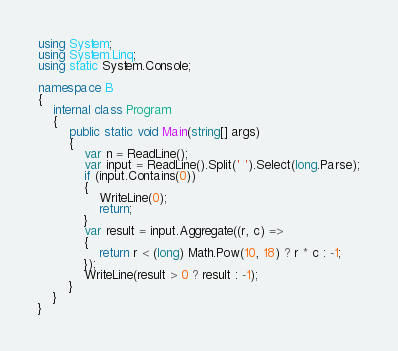Convert code to text. <code><loc_0><loc_0><loc_500><loc_500><_C#_>using System;
using System.Linq;
using static System.Console;

namespace B
{
    internal class Program
    {
        public static void Main(string[] args)
        {
            var n = ReadLine();
            var input = ReadLine().Split(' ').Select(long.Parse);
            if (input.Contains(0))
            {
                WriteLine(0);
                return;
            }
            var result = input.Aggregate((r, c) =>
            {
                return r < (long) Math.Pow(10, 18) ? r * c : -1;
            });
            WriteLine(result > 0 ? result : -1);
        }
    }
}</code> 